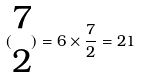<formula> <loc_0><loc_0><loc_500><loc_500>( \begin{matrix} 7 \\ 2 \end{matrix} ) = 6 \times \frac { 7 } { 2 } = 2 1</formula> 